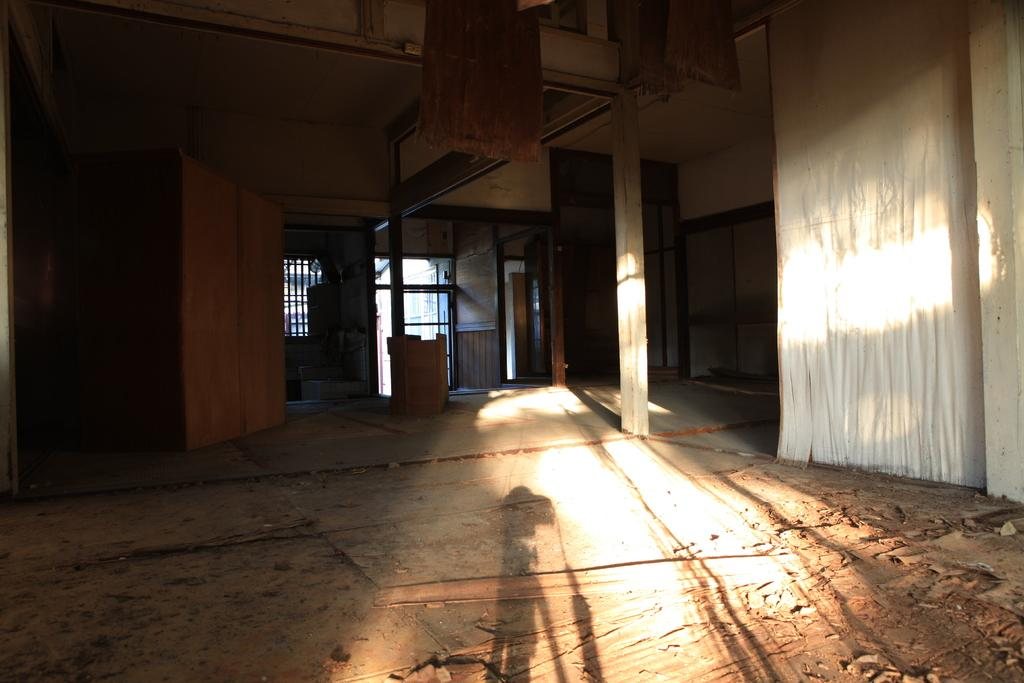What can be seen on the floor in the image? There is saw dust on the floor in the image. What type of openings are present in the image? There are doors and windows in the image. How many goldfish can be seen swimming in the image? There are no goldfish present in the image. What type of thread is being used to sew the doors in the image? There is no thread or sewing activity depicted in the image; it only shows doors and windows. 